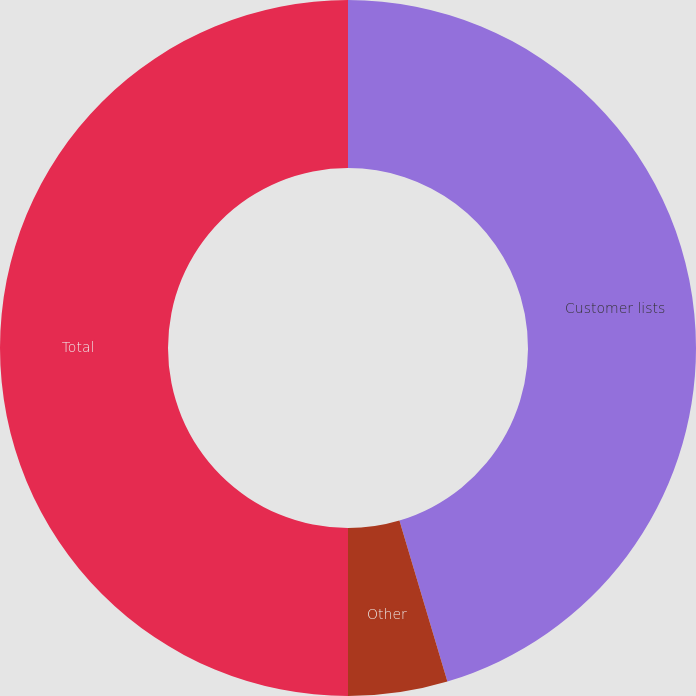Convert chart to OTSL. <chart><loc_0><loc_0><loc_500><loc_500><pie_chart><fcel>Customer lists<fcel>Other<fcel>Total<nl><fcel>45.39%<fcel>4.61%<fcel>50.0%<nl></chart> 